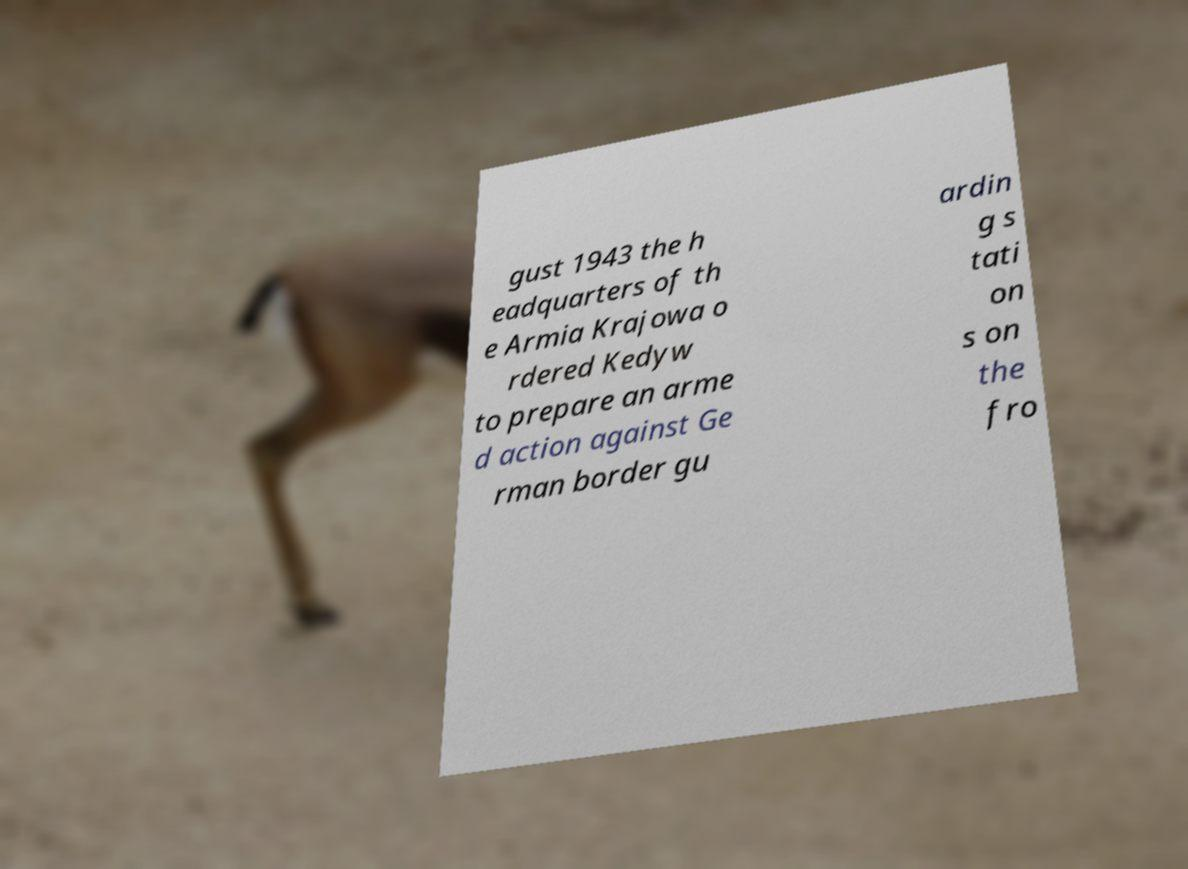Please read and relay the text visible in this image. What does it say? gust 1943 the h eadquarters of th e Armia Krajowa o rdered Kedyw to prepare an arme d action against Ge rman border gu ardin g s tati on s on the fro 